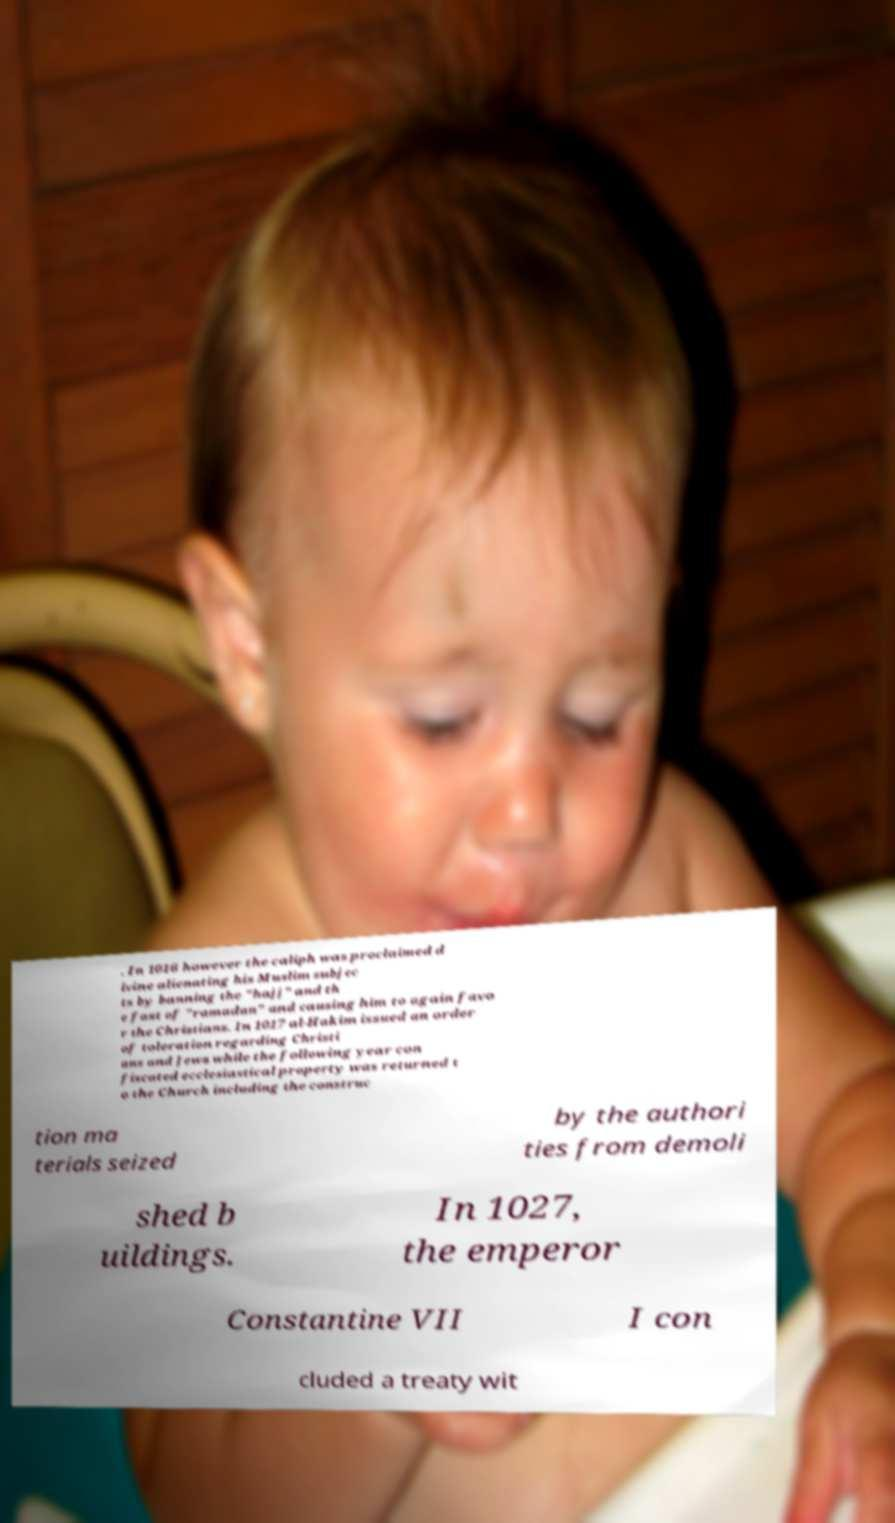For documentation purposes, I need the text within this image transcribed. Could you provide that? . In 1016 however the caliph was proclaimed d ivine alienating his Muslim subjec ts by banning the "hajj" and th e fast of "ramadan" and causing him to again favo r the Christians. In 1017 al-Hakim issued an order of toleration regarding Christi ans and Jews while the following year con fiscated ecclesiastical property was returned t o the Church including the construc tion ma terials seized by the authori ties from demoli shed b uildings. In 1027, the emperor Constantine VII I con cluded a treaty wit 